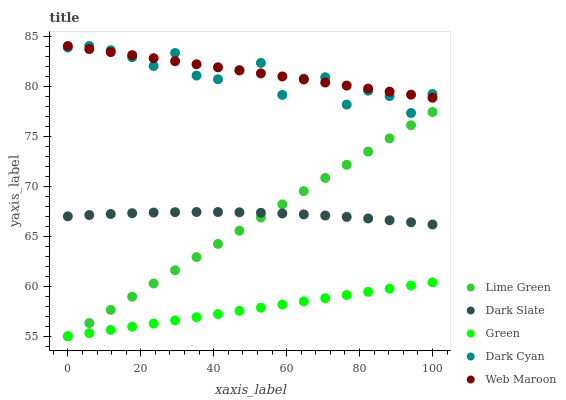Does Green have the minimum area under the curve?
Answer yes or no. Yes. Does Web Maroon have the maximum area under the curve?
Answer yes or no. Yes. Does Dark Slate have the minimum area under the curve?
Answer yes or no. No. Does Dark Slate have the maximum area under the curve?
Answer yes or no. No. Is Green the smoothest?
Answer yes or no. Yes. Is Dark Cyan the roughest?
Answer yes or no. Yes. Is Dark Slate the smoothest?
Answer yes or no. No. Is Dark Slate the roughest?
Answer yes or no. No. Does Green have the lowest value?
Answer yes or no. Yes. Does Dark Slate have the lowest value?
Answer yes or no. No. Does Web Maroon have the highest value?
Answer yes or no. Yes. Does Dark Slate have the highest value?
Answer yes or no. No. Is Lime Green less than Web Maroon?
Answer yes or no. Yes. Is Dark Cyan greater than Green?
Answer yes or no. Yes. Does Lime Green intersect Green?
Answer yes or no. Yes. Is Lime Green less than Green?
Answer yes or no. No. Is Lime Green greater than Green?
Answer yes or no. No. Does Lime Green intersect Web Maroon?
Answer yes or no. No. 